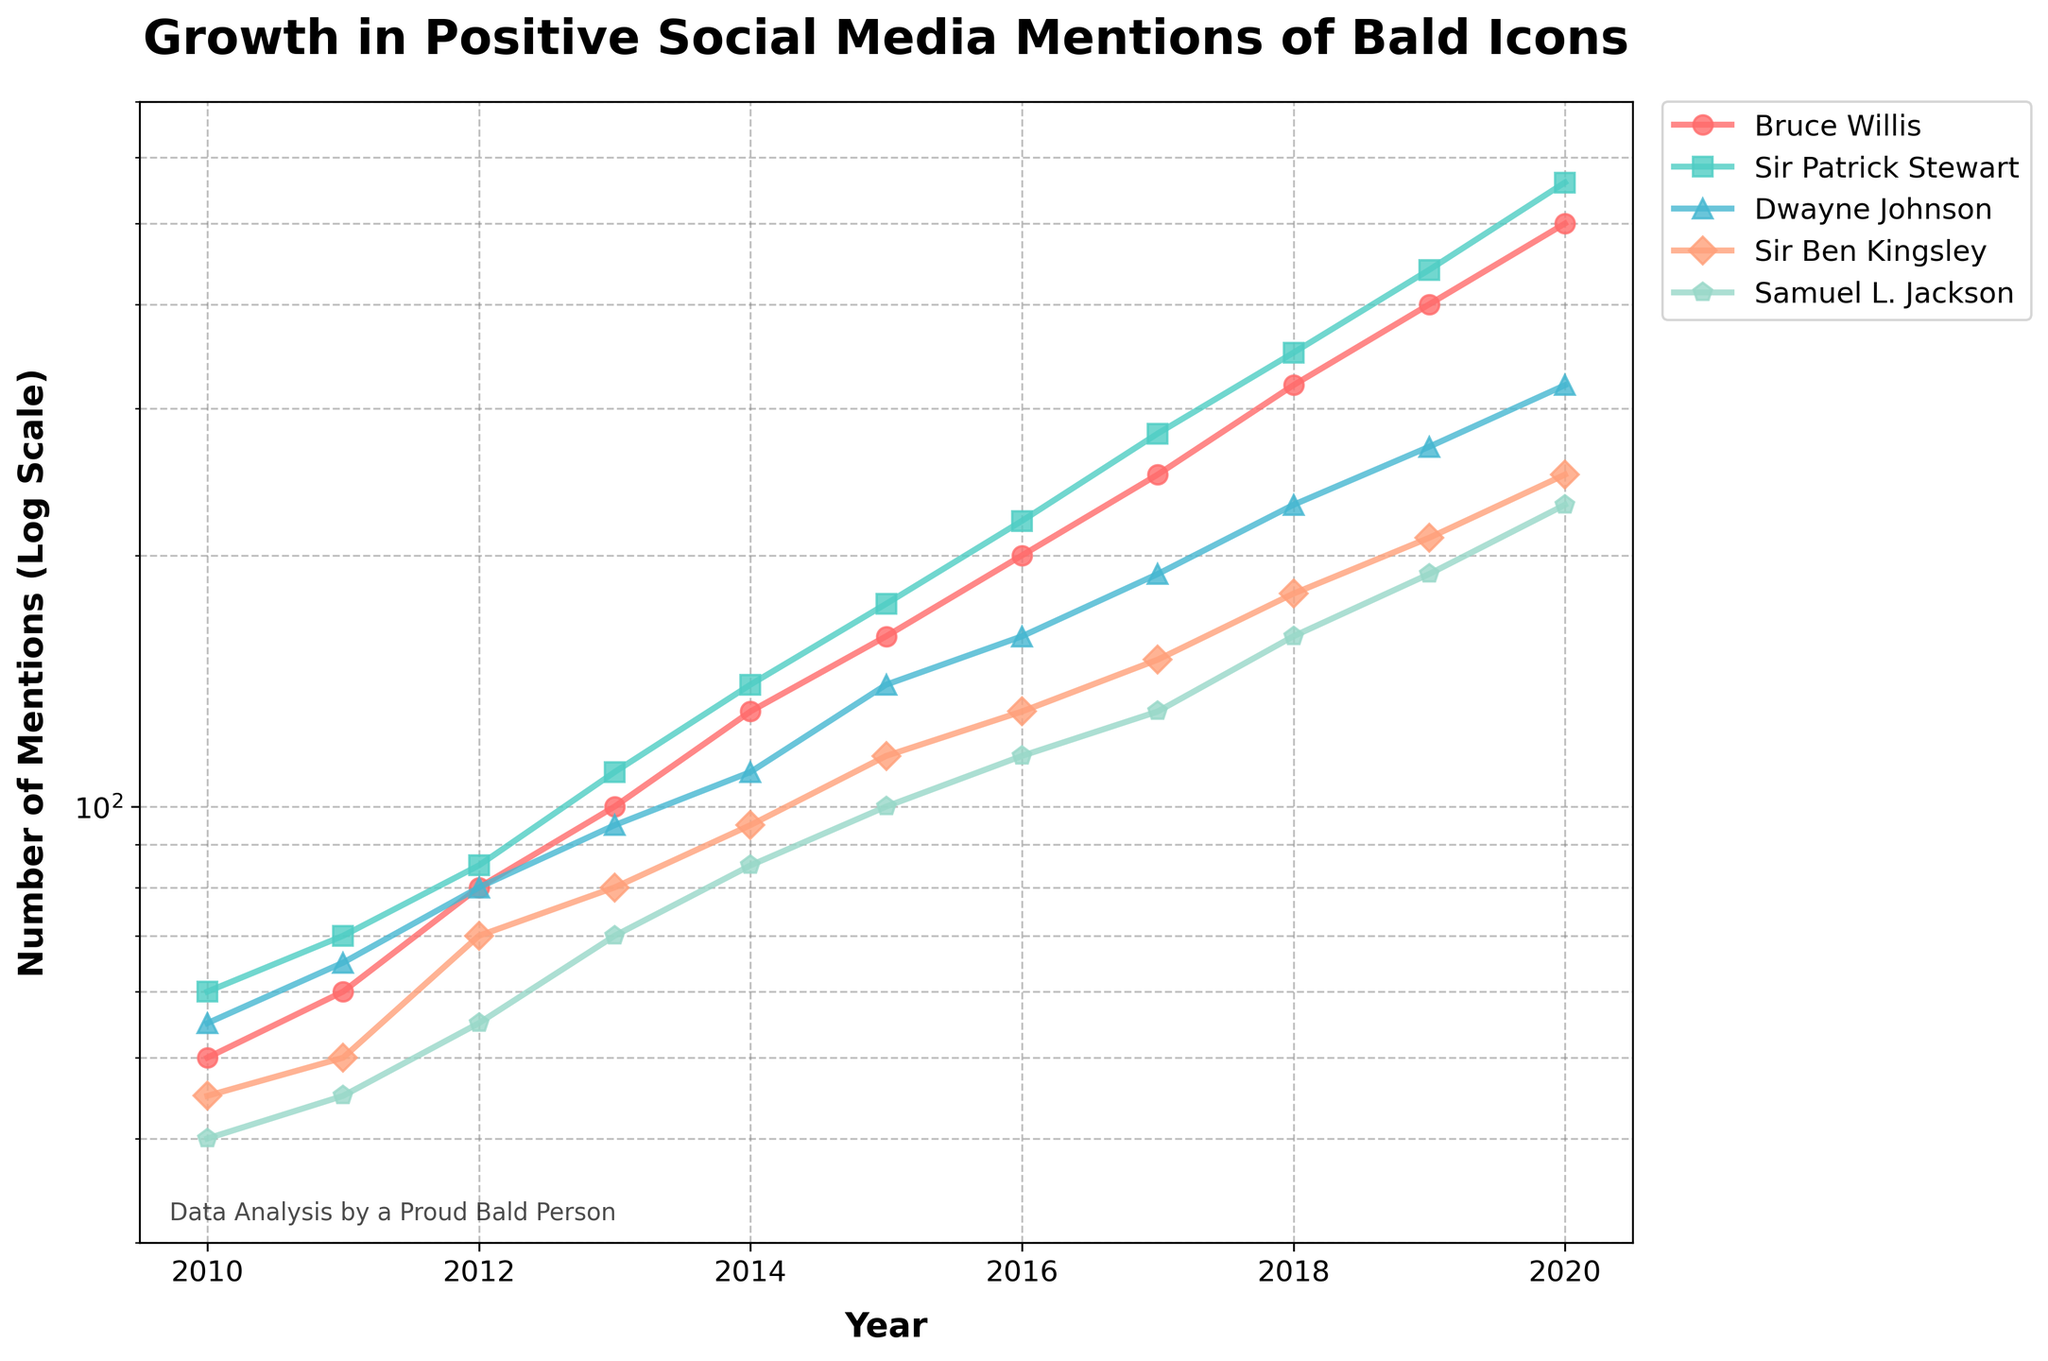What is the title of the plot? The title is located at the top center of the plot and reads "Growth in Positive Social Media Mentions of Bald Icons".
Answer: Growth in Positive Social Media Mentions of Bald Icons Which bald icon had the highest number of positive mentions in 2020? By observing the data points for the year 2020, Dwayne Johnson has the highest number of positive mentions as his line graph reaches up to 560.
Answer: Dwayne Johnson How many years are represented in the plot? Each data point on the x-axis corresponds to a different year. The plot starts at 2010 and ends at 2020, thus representing eleven years.
Answer: 11 What is the approximate number of mentions of Bruce Willis in 2015? Follow Bruce Willis’s line to the data point for the year 2015. The y-value is approximately 160.
Answer: 160 Who had more mentions in 2013, Sir Patrick Stewart or Sir Ben Kingsley? Looking at the plot for 2013, the line for Sir Patrick Stewart reaches 110, while Sir Ben Kingsley’s line reaches 80. Therefore, Sir Patrick Stewart had more mentions.
Answer: Sir Patrick Stewart Which bald icon showed the fastest rate of growth in mentions from 2010 to 2020? By comparing the slopes of the lines from 2010 to 2020, Dwayne Johnson shows the steepest increase, indicating the fastest rate of growth.
Answer: Dwayne Johnson What is the general trend for the mentions of these bald icons over the decade? All the lines show an upward trajectory over time, indicating that the number of positive mentions for each bald icon increases significantly from 2010 to 2020.
Answer: Increasing What was the approximate difference in mentions between Samuel L. Jackson and Bruce Willis in 2020? In 2020, Samuel L. Jackson had about 230 mentions while Bruce Willis had about 500 mentions. The difference is approximately 500 - 230 = 270.
Answer: 270 Who received the least amount of mentions in 2016, and how many were they? From the plot, Sir Ben Kingsley had the lowest data point in 2016 with about 130 mentions.
Answer: Sir Ben Kingsley, 130 